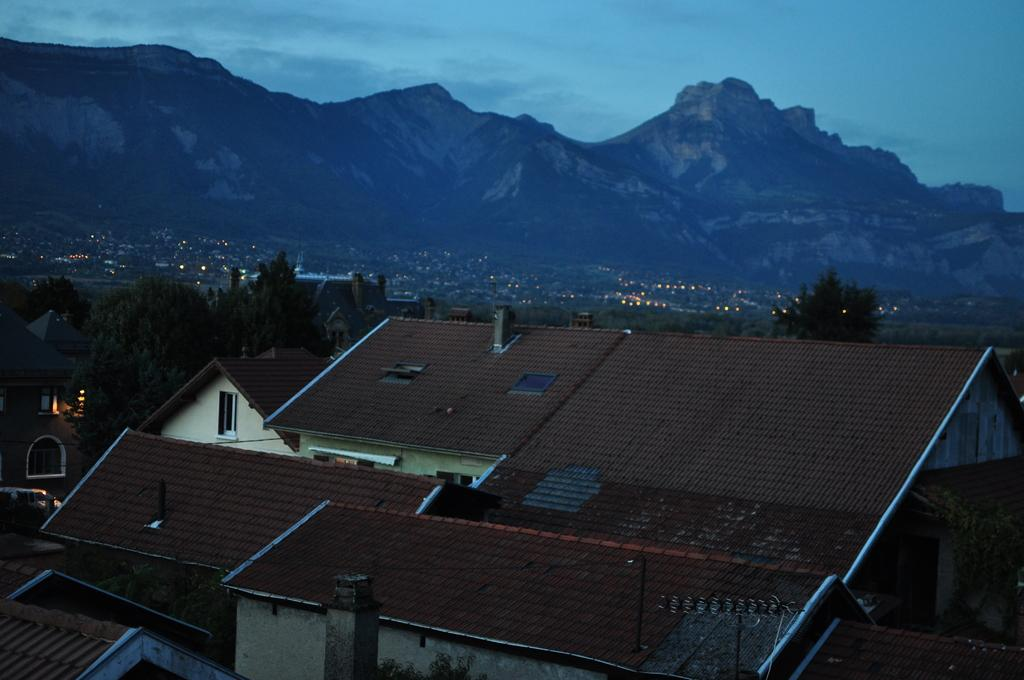What type of structures can be seen in the city? There are many houses in the city. What can be found between the houses? There are trees between the houses. What is visible in the background of the city? There are huge mountains in the background. Where is the cave located in the image? There is no cave present in the image. What type of bottle can be seen in the image? There is no bottle present in the image. 